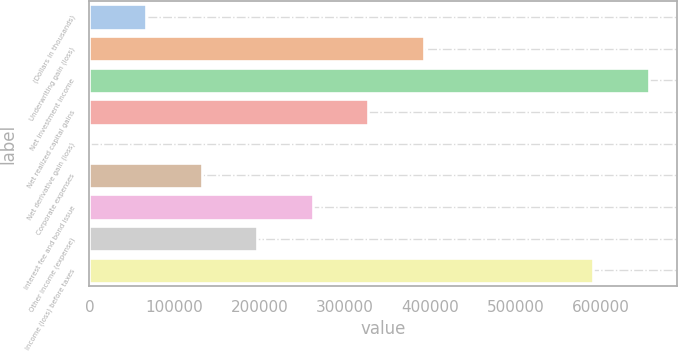<chart> <loc_0><loc_0><loc_500><loc_500><bar_chart><fcel>(Dollars in thousands)<fcel>Underwriting gain (loss)<fcel>Net investment income<fcel>Net realized capital gains<fcel>Net derivative gain (loss)<fcel>Corporate expenses<fcel>Interest fee and bond issue<fcel>Other income (expense)<fcel>Income (loss) before taxes<nl><fcel>66353.4<fcel>392525<fcel>656472<fcel>327291<fcel>1119<fcel>131588<fcel>262057<fcel>196822<fcel>591238<nl></chart> 